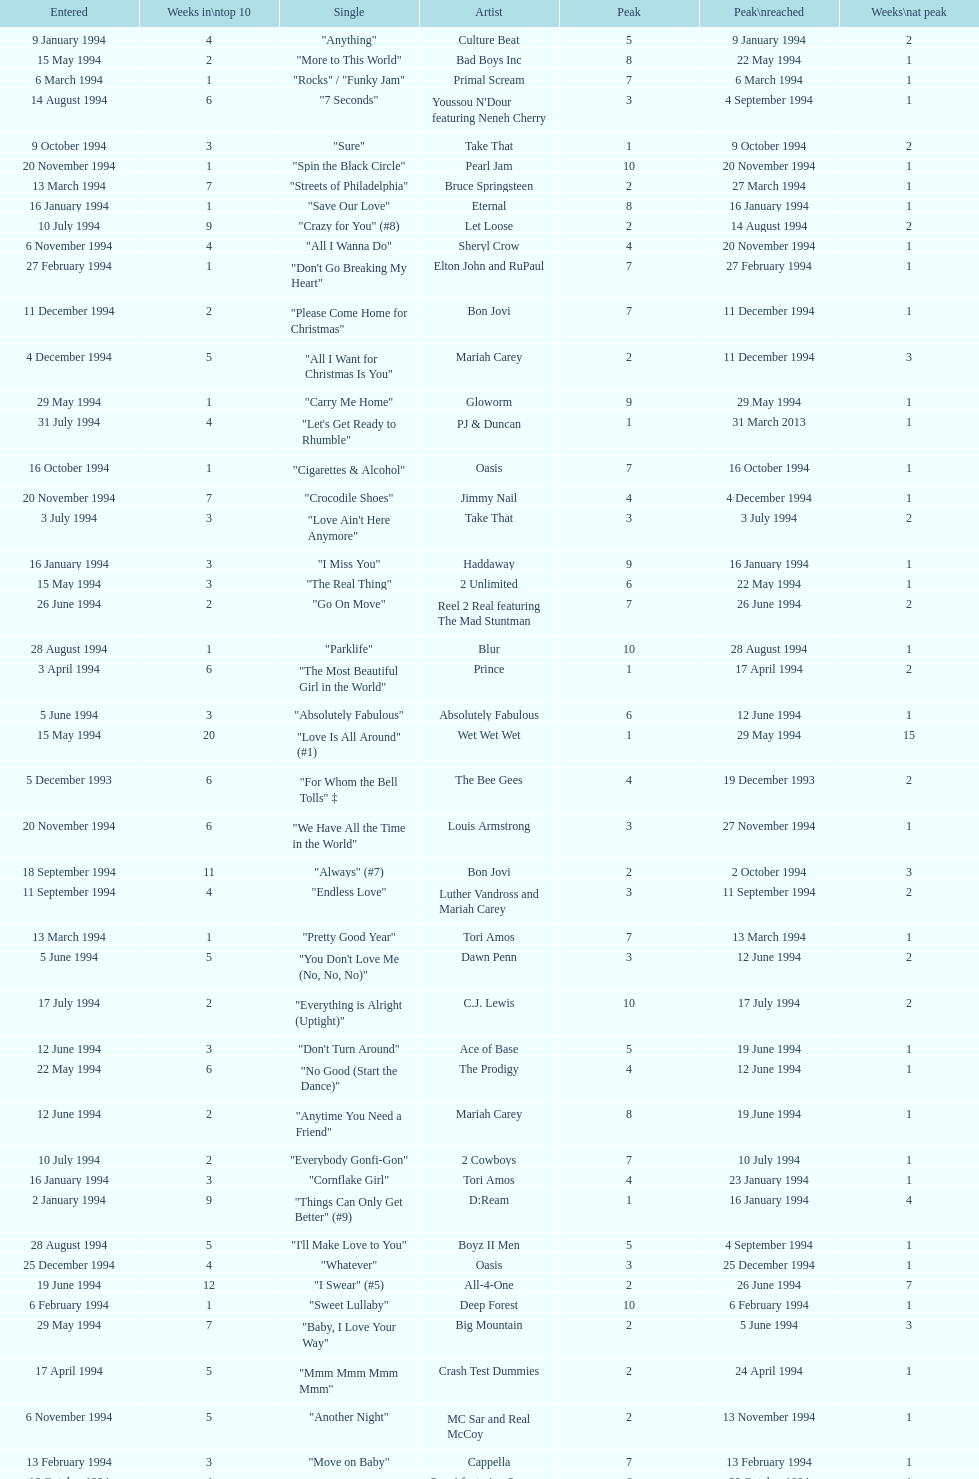Would you mind parsing the complete table? {'header': ['Entered', 'Weeks in\\ntop 10', 'Single', 'Artist', 'Peak', 'Peak\\nreached', 'Weeks\\nat peak'], 'rows': [['9 January 1994', '4', '"Anything"', 'Culture Beat', '5', '9 January 1994', '2'], ['15 May 1994', '2', '"More to This World"', 'Bad Boys Inc', '8', '22 May 1994', '1'], ['6 March 1994', '1', '"Rocks" / "Funky Jam"', 'Primal Scream', '7', '6 March 1994', '1'], ['14 August 1994', '6', '"7 Seconds"', "Youssou N'Dour featuring Neneh Cherry", '3', '4 September 1994', '1'], ['9 October 1994', '3', '"Sure"', 'Take That', '1', '9 October 1994', '2'], ['20 November 1994', '1', '"Spin the Black Circle"', 'Pearl Jam', '10', '20 November 1994', '1'], ['13 March 1994', '7', '"Streets of Philadelphia"', 'Bruce Springsteen', '2', '27 March 1994', '1'], ['16 January 1994', '1', '"Save Our Love"', 'Eternal', '8', '16 January 1994', '1'], ['10 July 1994', '9', '"Crazy for You" (#8)', 'Let Loose', '2', '14 August 1994', '2'], ['6 November 1994', '4', '"All I Wanna Do"', 'Sheryl Crow', '4', '20 November 1994', '1'], ['27 February 1994', '1', '"Don\'t Go Breaking My Heart"', 'Elton John and RuPaul', '7', '27 February 1994', '1'], ['11 December 1994', '2', '"Please Come Home for Christmas"', 'Bon Jovi', '7', '11 December 1994', '1'], ['4 December 1994', '5', '"All I Want for Christmas Is You"', 'Mariah Carey', '2', '11 December 1994', '3'], ['29 May 1994', '1', '"Carry Me Home"', 'Gloworm', '9', '29 May 1994', '1'], ['31 July 1994', '4', '"Let\'s Get Ready to Rhumble"', 'PJ & Duncan', '1', '31 March 2013', '1'], ['16 October 1994', '1', '"Cigarettes & Alcohol"', 'Oasis', '7', '16 October 1994', '1'], ['20 November 1994', '7', '"Crocodile Shoes"', 'Jimmy Nail', '4', '4 December 1994', '1'], ['3 July 1994', '3', '"Love Ain\'t Here Anymore"', 'Take That', '3', '3 July 1994', '2'], ['16 January 1994', '3', '"I Miss You"', 'Haddaway', '9', '16 January 1994', '1'], ['15 May 1994', '3', '"The Real Thing"', '2 Unlimited', '6', '22 May 1994', '1'], ['26 June 1994', '2', '"Go On Move"', 'Reel 2 Real featuring The Mad Stuntman', '7', '26 June 1994', '2'], ['28 August 1994', '1', '"Parklife"', 'Blur', '10', '28 August 1994', '1'], ['3 April 1994', '6', '"The Most Beautiful Girl in the World"', 'Prince', '1', '17 April 1994', '2'], ['5 June 1994', '3', '"Absolutely Fabulous"', 'Absolutely Fabulous', '6', '12 June 1994', '1'], ['15 May 1994', '20', '"Love Is All Around" (#1)', 'Wet Wet Wet', '1', '29 May 1994', '15'], ['5 December 1993', '6', '"For Whom the Bell Tolls" ‡', 'The Bee Gees', '4', '19 December 1993', '2'], ['20 November 1994', '6', '"We Have All the Time in the World"', 'Louis Armstrong', '3', '27 November 1994', '1'], ['18 September 1994', '11', '"Always" (#7)', 'Bon Jovi', '2', '2 October 1994', '3'], ['11 September 1994', '4', '"Endless Love"', 'Luther Vandross and Mariah Carey', '3', '11 September 1994', '2'], ['13 March 1994', '1', '"Pretty Good Year"', 'Tori Amos', '7', '13 March 1994', '1'], ['5 June 1994', '5', '"You Don\'t Love Me (No, No, No)"', 'Dawn Penn', '3', '12 June 1994', '2'], ['17 July 1994', '2', '"Everything is Alright (Uptight)"', 'C.J. Lewis', '10', '17 July 1994', '2'], ['12 June 1994', '3', '"Don\'t Turn Around"', 'Ace of Base', '5', '19 June 1994', '1'], ['22 May 1994', '6', '"No Good (Start the Dance)"', 'The Prodigy', '4', '12 June 1994', '1'], ['12 June 1994', '2', '"Anytime You Need a Friend"', 'Mariah Carey', '8', '19 June 1994', '1'], ['10 July 1994', '2', '"Everybody Gonfi-Gon"', '2 Cowboys', '7', '10 July 1994', '1'], ['16 January 1994', '3', '"Cornflake Girl"', 'Tori Amos', '4', '23 January 1994', '1'], ['2 January 1994', '9', '"Things Can Only Get Better" (#9)', 'D:Ream', '1', '16 January 1994', '4'], ['28 August 1994', '5', '"I\'ll Make Love to You"', 'Boyz II Men', '5', '4 September 1994', '1'], ['25 December 1994', '4', '"Whatever"', 'Oasis', '3', '25 December 1994', '1'], ['19 June 1994', '12', '"I Swear" (#5)', 'All-4-One', '2', '26 June 1994', '7'], ['6 February 1994', '1', '"Sweet Lullaby"', 'Deep Forest', '10', '6 February 1994', '1'], ['29 May 1994', '7', '"Baby, I Love Your Way"', 'Big Mountain', '2', '5 June 1994', '3'], ['17 April 1994', '5', '"Mmm Mmm Mmm Mmm"', 'Crash Test Dummies', '2', '24 April 1994', '1'], ['6 November 1994', '5', '"Another Night"', 'MC Sar and Real McCoy', '2', '13 November 1994', '1'], ['13 February 1994', '3', '"Move on Baby"', 'Cappella', '7', '13 February 1994', '1'], ['16 October 1994', '4', '"Welcome to Tomorrow (Are You Ready?)"', 'Snap! featuring Summer', '6', '30 October 1994', '1'], ['19 December 1993', '3', '"Bat Out of Hell" ‡', 'Meat Loaf', '8', '19 December 1993', '2'], ['4 December 1994', '8', '"Love Me for a Reason" ♦', 'Boyzone', '2', '1 January 1995', '1'], ['16 January 1994', '1', '"Here I Stand"', 'Bitty McLean', '10', '16 January 1994', '1'], ['10 April 1994', '6', '"The Real Thing"', 'Tony Di Bart', '1', '1 May 1994', '1'], ['22 May 1994', '5', '"Get-A-Way"', 'Maxx', '4', '29 May 1994', '2'], ['6 February 1994', '1', '"Come In Out of the Rain"', 'Wendy Moten', '8', '6 February 1994', '1'], ['9 January 1994', '8', '"All for Love"', 'Bryan Adams, Rod Stewart and Sting', '2', '23 January 1994', '1'], ['8 May 1994', '3', '"Just a Step from Heaven"', 'Eternal', '8', '15 May 1994', '1'], ['27 November 1994', '8', '"Stay Another Day" (#3)', 'East 17', '1', '4 December 1994', '5'], ['6 March 1994', '2', '"Renaissance"', 'M People', '5', '6 March 1994', '1'], ['20 March 1994', '2', '"Dry County"', 'Bon Jovi', '9', '27 March 1994', '1'], ['2 October 1994', '10', '"Baby Come Back" (#4)', 'Pato Banton featuring Ali and Robin Campbell', '1', '23 October 1994', '4'], ['17 April 1994', '3', '"Dedicated to the One I Love"', 'Bitty McLean', '6', '24 April 1994', '1'], ['31 July 1994', '2', '"No More (I Can\'t Stand It)"', 'Maxx', '8', '7 August 1994', '1'], ['11 September 1994', '3', '"Incredible"', 'M-Beat featuring General Levy', '8', '18 September 1994', '1'], ['11 September 1994', '2', '"What\'s the Frequency, Kenneth"', 'R.E.M.', '9', '11 September 1994', '1'], ['17 July 1994', '8', '"Regulate"', 'Warren G and Nate Dogg', '5', '24 July 1994', '1'], ['27 November 1994', '2', '"Love Spreads"', 'The Stone Roses', '2', '27 November 1994', '1'], ['30 October 1994', '4', '"Oh Baby I..."', 'Eternal', '4', '6 November 1994', '1'], ['3 July 1994', '2', '"Word Up!"', 'GUN', '8', '3 July 1994', '1'], ['23 January 1994', '8', '"Return to Innocence"', 'Enigma', '3', '6 February 1994', '2'], ['12 December 1993', '7', '"Twist and Shout"', 'Chaka Demus & Pliers featuring Jack Radics and Taxi Gang', '1', '2 January 1994', '2'], ['20 February 1994', '2', '"Stay Together"', 'Suede', '3', '20 February 1994', '1'], ['13 November 1994', '5', '"Let Me Be Your Fantasy"', 'Baby D', '1', '20 November 1994', '2'], ['10 April 1994', '2', '"Rock My Heart"', 'Haddaway', '9', '10 April 1994', '2'], ['26 June 1994', '1', '"U & Me"', 'Cappella', '10', '26 June 1994', '1'], ['27 March 1994', '3', '"I\'ll Remember"', 'Madonna', '7', '3 April 1994', '1'], ['25 September 1994', '6', '"Stay (I Missed You)"', 'Lisa Loeb and Nine Stories', '6', '25 September 1994', '1'], ['4 December 1994', '17', '"Think Twice" ♦', 'Celine Dion', '1', '29 January 1995', '7'], ['2 October 1994', '6', '"Sweetness"', 'Michelle Gayle', '4', '30 October 1994', '1'], ['13 November 1994', '3', '"Sight for Sore Eyes"', 'M People', '6', '20 November 1994', '1'], ['5 December 1993', '7', '"It\'s Alright"', 'East 17', '3', '9 January 1994', '1'], ['5 June 1994', '1', '"Since I Don\'t Have You"', 'Guns N Roses', '10', '5 June 1994', '1'], ['4 September 1994', '3', '"Confide in Me"', 'Kylie Minogue', '2', '4 September 1994', '1'], ['6 February 1994', '11', '"I Like to Move It"', 'Reel 2 Real featuring The Mad Stuntman', '5', '27 March 1994', '1'], ['3 October 1993', '14', '"I\'d Do Anything for Love" ‡ (#1)', 'Meat Loaf', '1', '17 October 1993', '7'], ['24 April 1994', '6', '"Sweets for My Sweet"', 'C.J. Lewis', '3', '1 May 1994', '1'], ['24 April 1994', '1', '"I\'ll Stand by You"', 'The Pretenders', '10', '24 April 1994', '1'], ['20 March 1994', '2', '"Shine On"', 'Degrees of Motion featuring Biti', '8', '27 March 1994', '1'], ['7 August 1994', '4', '"What\'s Up?"', 'DJ Miko', '6', '14 August 1994', '1'], ['6 March 1994', '1', '"The More You Ignore Me, The Closer I Get"', 'Morrissey', '8', '6 March 1994', '1'], ['1 May 1994', '2', '"Light My Fire"', 'Clubhouse featuring Carl', '7', '1 May 1994', '1'], ['30 October 1994', '2', '"Some Girls"', 'Ultimate Kaos', '9', '30 October 1994', '1'], ['11 December 1994', '3', '"Power Rangers: The Official Single"', 'The Mighty RAW', '3', '11 December', '1'], ['26 June 1994', '6', '"Shine"', 'Aswad', '5', '17 July 1994', '1'], ['25 September 1994', '3', '"Steam"', 'East 17', '7', '25 September 1994', '2'], ['30 January 1994', '1', '"Give It Away"', 'Red Hot Chili Peppers', '9', '30 January 1994', '1'], ['20 February 1994', '9', '"The Sign"', 'Ace of Base', '2', '27 February 1994', '3'], ['1 May 1994', '6', '"Inside"', 'Stiltskin', '1', '8 May 1994', '1'], ['23 October 1994', '1', '"When We Dance"', 'Sting', '9', '23 October 1994', '1'], ['28 November 1993', '7', '"Mr Blobby" ‡ (#6)', 'Mr Blobby', '1', '5 December 1993', '3'], ['2 October 1994', '2', '"Secret"', 'Madonna', '5', '2 October 1994', '1'], ['3 July 1994', '7', '"(Meet) The Flintstones"', 'The B.C. 52s', '3', '17 July 1994', '3'], ['16 October 1994', '5', '"She\'s Got That Vibe"', 'R. Kelly', '3', '6 November 1994', '1'], ['4 September 1994', '6', '"The Rhythm of the Night"', 'Corona', '2', '18 September 1994', '2'], ['13 March 1994', '2', '"Girls & Boys"', 'Blur', '5', '13 March 1994', '1'], ['1 May 1994', '7', '"Come on You Reds"', 'Manchester United Football Squad featuring Status Quo', '1', '15 May 1994', '2'], ['6 March 1994', '6', '"Doop" (#10)', 'Doop', '1', '13 March 1994', '3'], ['6 February 1994', '2', '"A Deeper Love"', 'Aretha Franklin featuring Lisa Fischer', '5', '6 February 1994', '1'], ['13 February 1994', '4', '"Let the Beat Control Your Body"', '2 Unlimited', '6', '27 February 1994', '1'], ['11 December 1994', '2', '"Another Day" ♦', 'Whigfield', '7', '1 January 1995', '1'], ['3 April 1994', '4', '"Everything Changes"', 'Take That', '1', '3 April 1994', '2'], ['30 January 1994', '4', '"The Power of Love"', 'Céline Dion', '4', '6 February 1994', '1'], ['14 August 1994', '2', '"Live Forever"', 'Oasis', '10', '14 August 1994', '2'], ['23 January 1994', '8', '"Breathe Again"', 'Toni Braxton', '2', '30 January 1994', '2'], ['20 March 1994', '4', '"U R The Best Thing"', 'D:Ream', '4', '27 March 1994', ''], ['13 February 1994', '8', '"Without You" (#6)', 'Mariah Carey', '1', '13 February 1994', '4'], ['8 May 1994', '5', '"Around the World"', 'East 17', '3', '15 May 1994', '2'], ['23 January 1994', '1', '"In Your Room"', 'Depeche Mode', '8', '23 January 1994', '1'], ['21 August 1994', '1', '"Eighteen Strings"', 'Tinman', '9', '21 August 1994', '1'], ['20 March 1994', '3', '"Whatta Man"', 'Salt-N-Pepa with En Vogue', '7', '20 March 1994', '1'], ['12 December 1993', '5', '"Babe" ‡', 'Take That', '1', '12 December 1993', '1'], ['18 December 1994', '4', '"Them Girls, Them Girls" ♦', 'Zig and Zag', '5', '1 January 1995', '1'], ['25 September 1994', '6', '"Hey Now (Girls Just Want to Have Fun)"', 'Cyndi Lauper', '4', '2 October 1994', '1'], ['26 December 1993', '7', '"Come Baby Come"', 'K7', '3', '16 January 1994', '2'], ['13 November 1994', '1', '"True Faith \'94"', 'New Order', '9', '13 November 1994', '1'], ['11 September 1994', '10', '"Saturday Night" (#2)', 'Whigfield', '1', '11 September 1994', '4'], ['18 December 1994', '10', '"Cotton Eye Joe" ♦', 'Rednex', '1', '8 January 1995', '3'], ['12 December 1993', '5', '"The Perfect Year"', 'Dina Carroll', '5', '2 January 1994', '1'], ['12 June 1994', '8', '"Swamp Thing"', 'The Grid', '3', '26 June 1994', '1'], ['17 April 1994', '4', '"Always"', 'Erasure', '4', '17 April 1994', '2'], ['24 July 1994', '7', '"Searching"', 'China Black', '4', '7 August 1994', '2'], ['7 August 1994', '6', '"Compliments on Your Kiss"', 'Red Dragon with Brian and Tony Gold', '2', '28 August 1994', '1'], ['24 July 1994', '1', '"Run to the Sun"', 'Erasure', '6', '24 July 1994', '1']]} Which artist only has its single entered on 2 january 1994? D:Ream. 